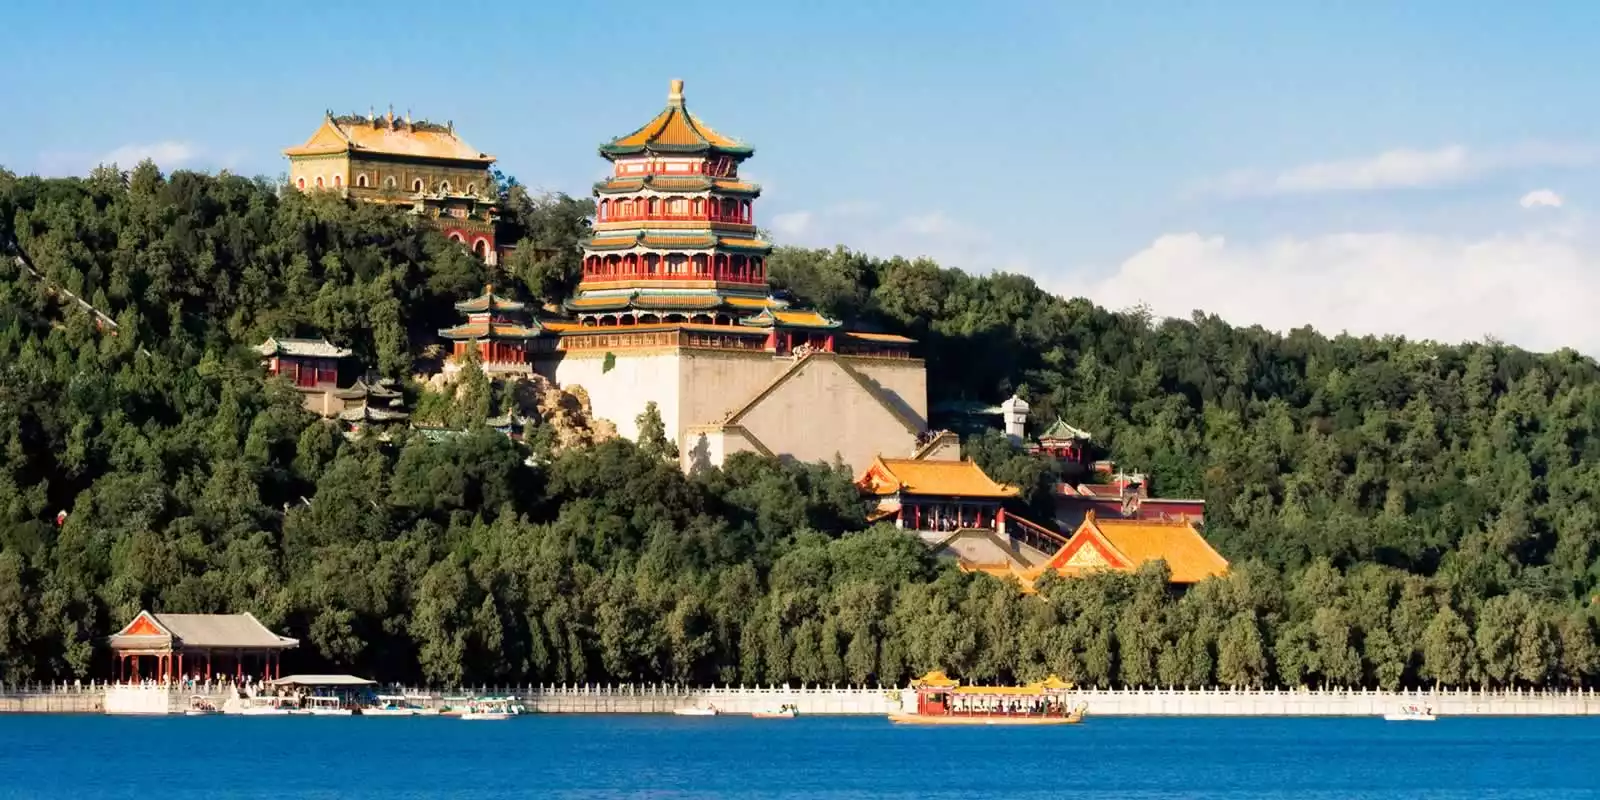Describe the ambiance of the Summer Palace as the seasons change. The ambiance of the Summer Palace transforms beautifully with the changing seasons, each bringing its unique charm and character. In spring, the palace grounds burst into a riot of colors as cherry blossoms and plum trees bloom, their delicate petals creating a picturesque contrast against the red and gold architecture. The air is filled with the fragrance of fresh flowers, and the lake is dotted with budding lotus leaves. Summer envelops the palace in lush greenery, with the dense foliage providing cool, shaded areas for serene strolls. The lake becomes a hub of activity, with boats leisurely gliding across its sparkling blue waters, reflecting the clear sky above. As autumn arrives, the landscape is painted in hues of gold, orange, and red, with the trees shedding their leaves in a mesmerizing dance. The crisp, cool air enhances the tranquil and contemplative atmosphere, making it an ideal time for quiet reflection. Winter drapes the palace in a serene blanket of snow, transforming it into a tranquil wonderland. The lake, partially frozen, adds to the ethereal beauty of the scene, with the stark white landscape accentuating the vivid colors of the palace structures. Each season brings a unique ambiance to the Summer Palace, showcasing the harmonious interplay between nature and architecture. 